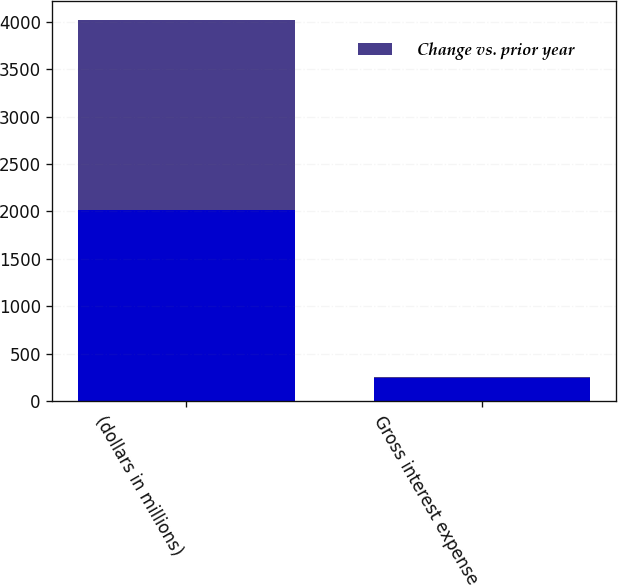<chart> <loc_0><loc_0><loc_500><loc_500><stacked_bar_chart><ecel><fcel>(dollars in millions)<fcel>Gross interest expense<nl><fcel>nan<fcel>2013<fcel>237<nl><fcel>Change vs. prior year<fcel>2013<fcel>9.9<nl></chart> 